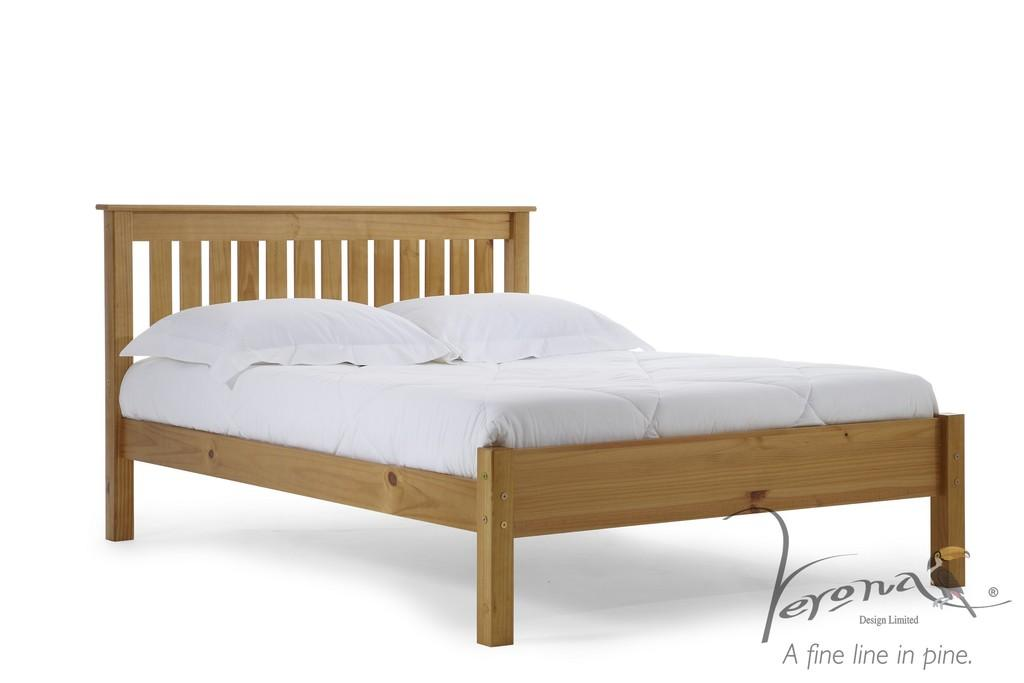What type of bed is in the image? There is a wooden bed in the image. What color are the pillows on the bed? The pillows on the bed have a white color. What color is the mattress on the bed? The mattress on the bed is also white in color. Is there any additional information about the image itself? Yes, there is a watermark in the right bottom of the image. What type of marble is used to decorate the bed in the image? There is no marble present in the image; the bed is made of wood, and the pillows and mattress are white in color. 